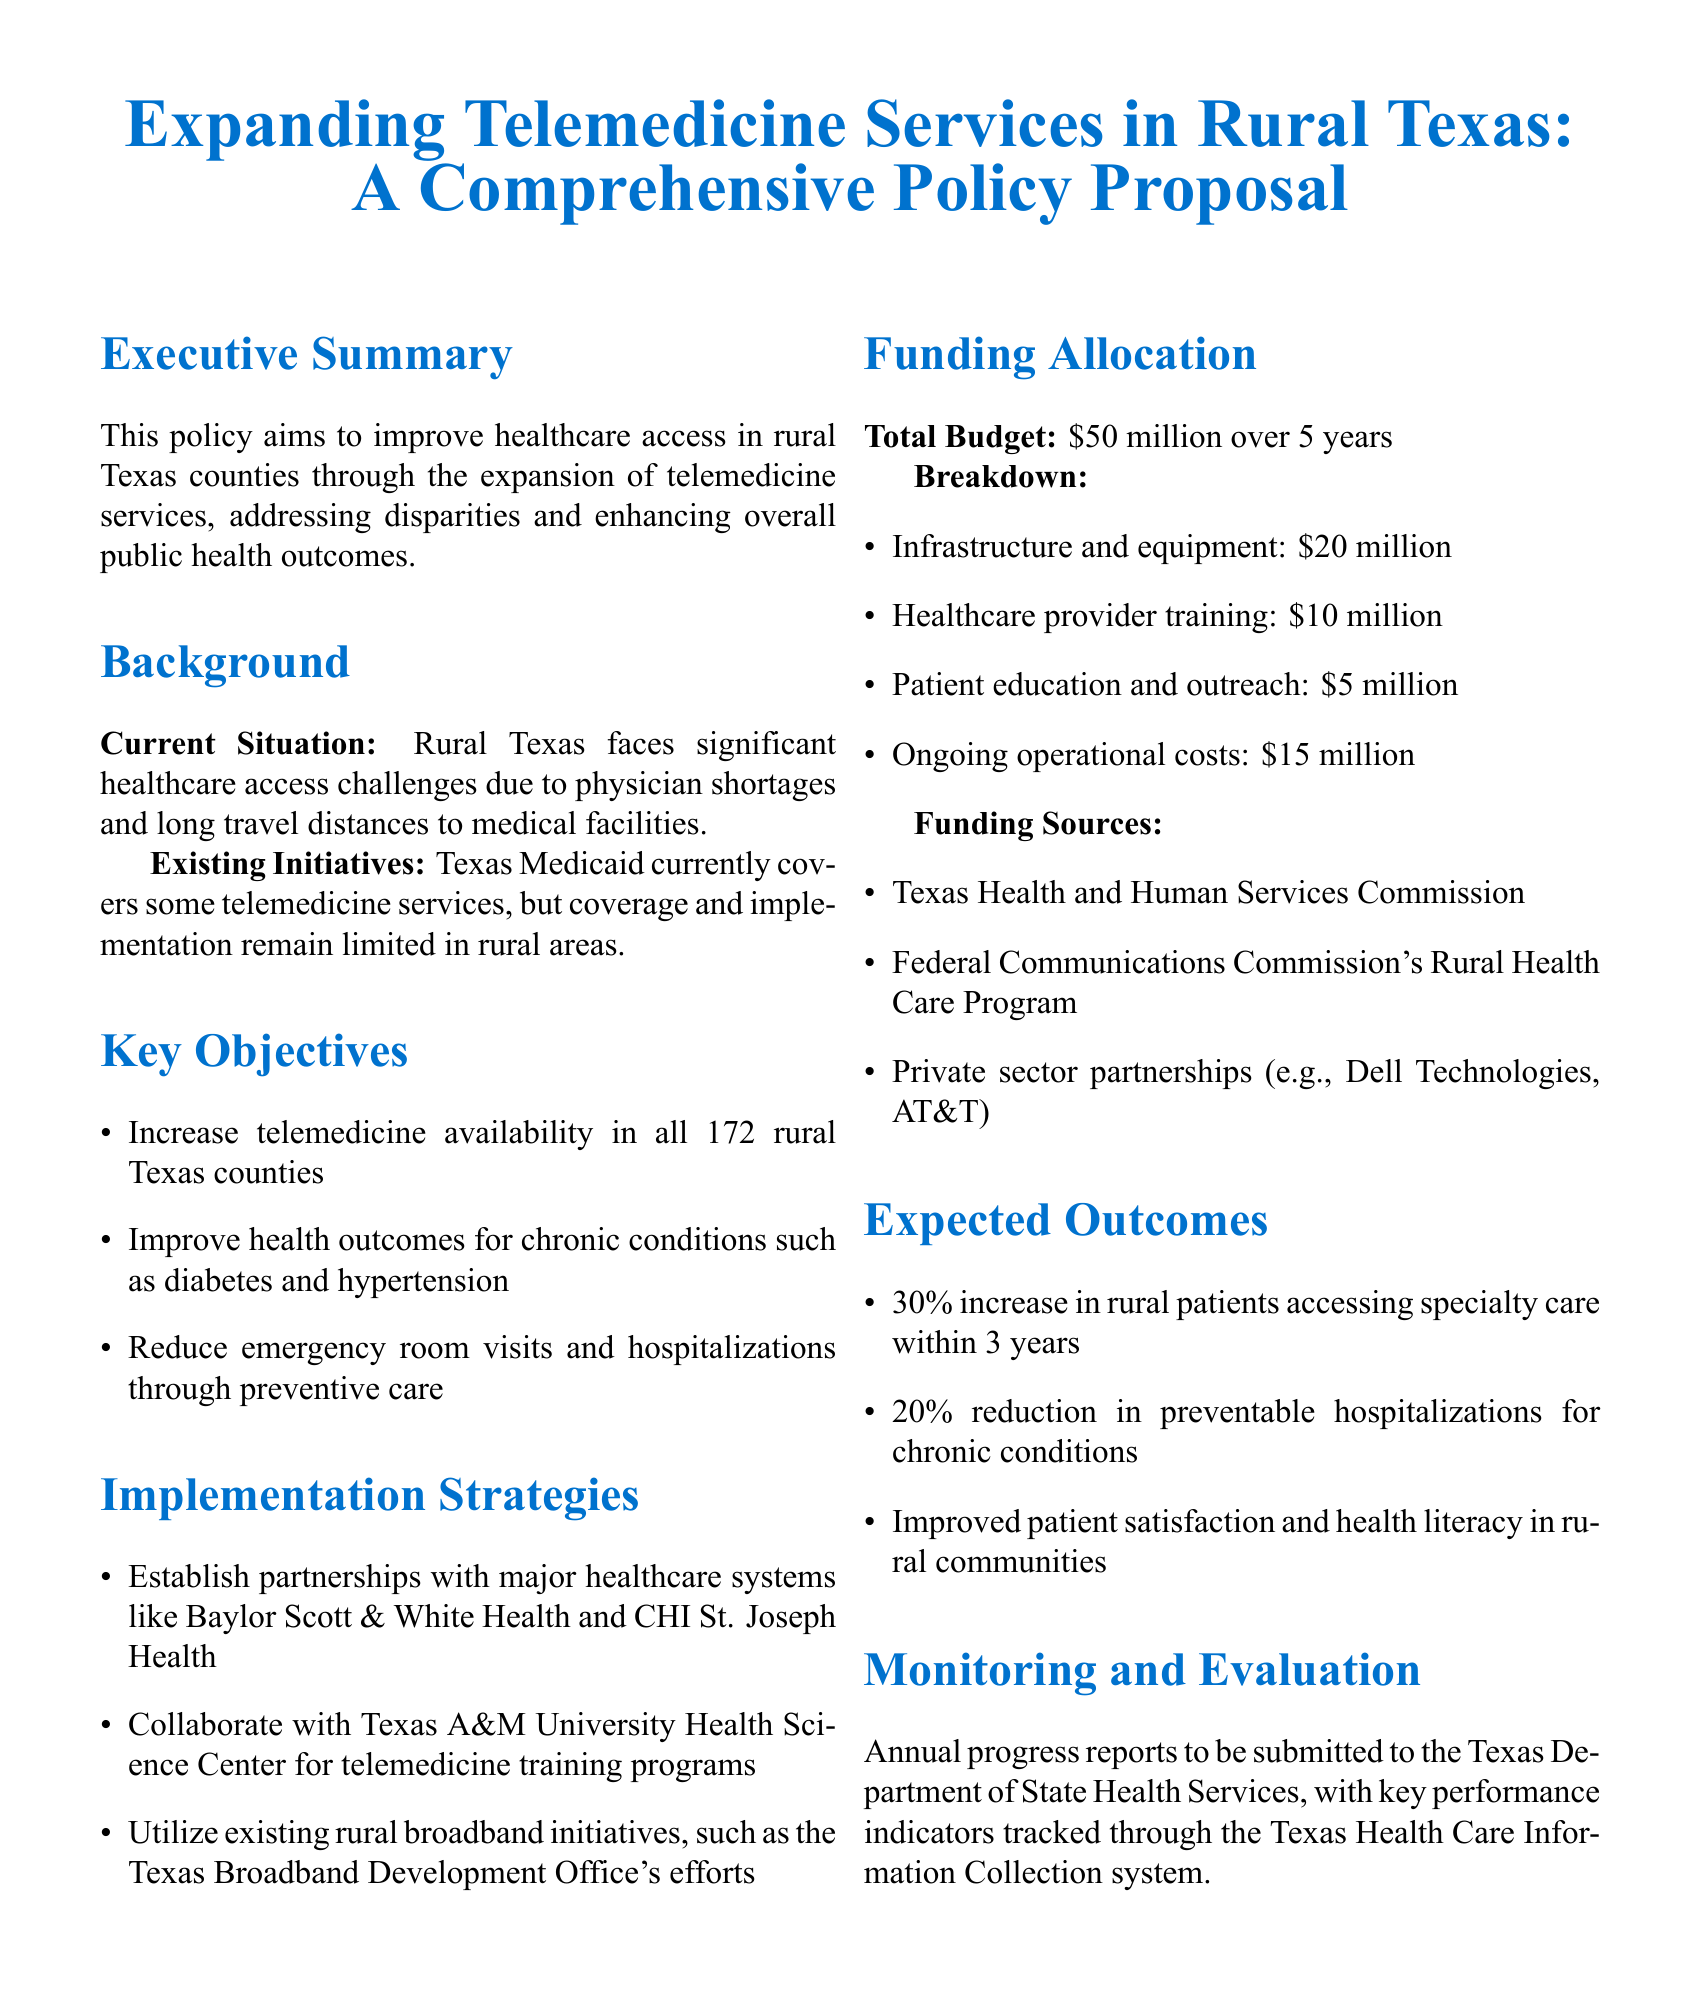What is the total budget for the proposal? The total budget is explicitly stated in the Funding Allocation section of the document.
Answer: $50 million How many rural Texas counties are targeted for telemedicine expansion? The specific number of rural Texas counties is mentioned in the Key Objectives section.
Answer: 172 What is one of the key objectives related to chronic conditions? The objectives related to chronic conditions are detailed in the Key Objectives section.
Answer: Improve health outcomes for chronic conditions such as diabetes and hypertension Who is a potential partner for telemedicine training programs? The collaboration partner for telemedicine training is indicated in the Implementation Strategies section.
Answer: Texas A&M University Health Science Center What percentage increase in rural patients accessing specialty care is expected? The expected percentage increase in rural patient access is stated in the Expected Outcomes section.
Answer: 30% What is allocated for patient education and outreach in the budget? The specific allocation for patient education and outreach is found in the Funding Allocation breakdown.
Answer: $5 million Which organization is responsible for submitting annual progress reports? The organization responsible for progress reports is mentioned in the Monitoring and Evaluation section.
Answer: Texas Department of State Health Services What is one funding source mentioned in the document? The funding sources are listed in the Funding Allocation section, indicating various contributors.
Answer: Texas Health and Human Services Commission 